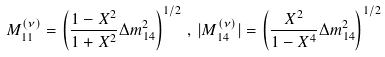Convert formula to latex. <formula><loc_0><loc_0><loc_500><loc_500>M ^ { ( \nu ) } _ { 1 1 } = \left ( \frac { 1 - X ^ { 2 } } { 1 + X ^ { 2 } } \Delta m ^ { 2 } _ { 1 4 } \right ) ^ { 1 / 2 } \, , \, | M ^ { ( \nu ) } _ { 1 4 } | = \left ( \frac { X ^ { 2 } } { 1 - X ^ { 4 } } \Delta m ^ { 2 } _ { 1 4 } \right ) ^ { 1 / 2 }</formula> 